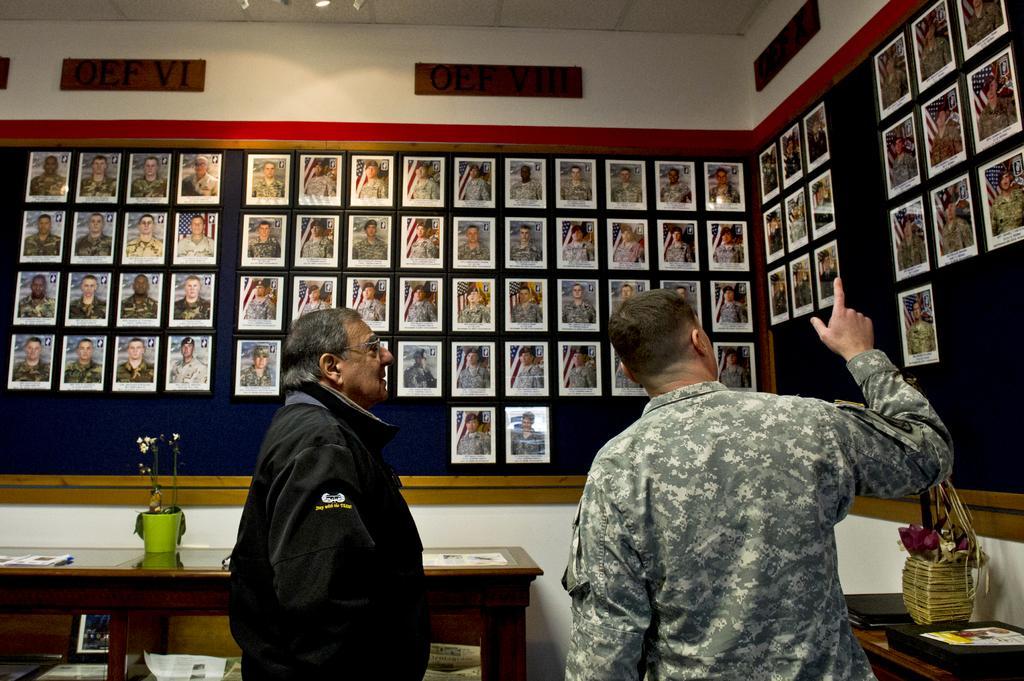In one or two sentences, can you explain what this image depicts? In this image i can see two man standing and talking about the photograph attached on the wall, at the back ground i can see a table, a pot on the table. 